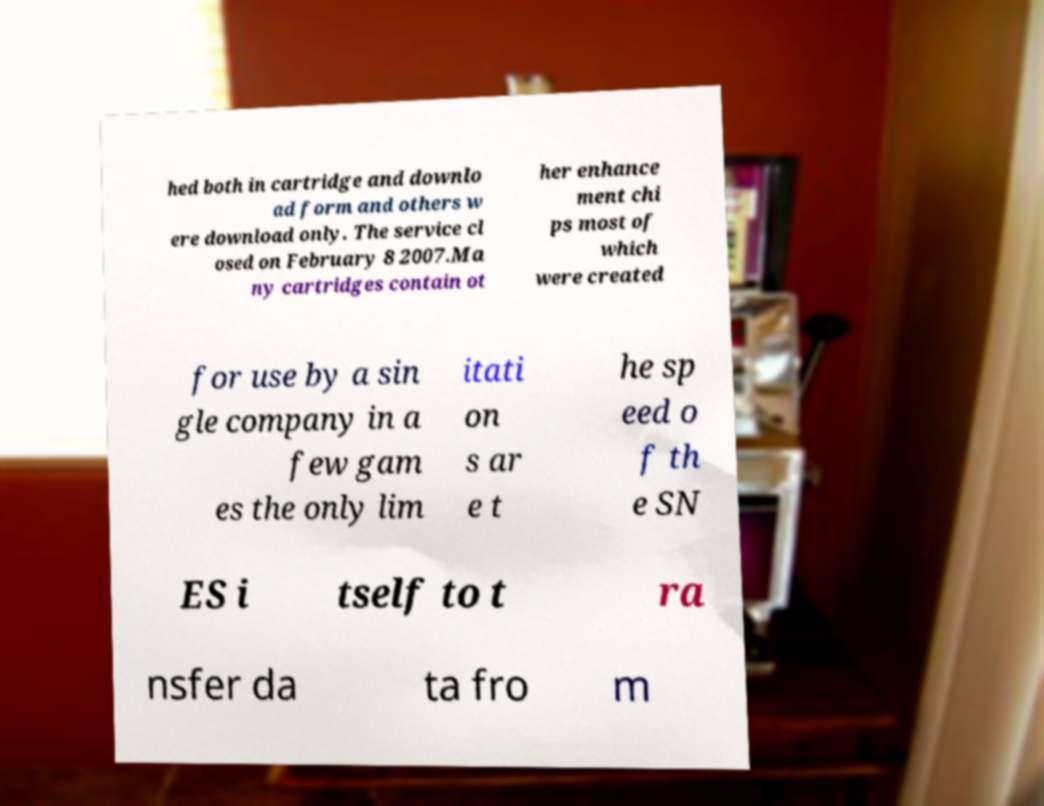I need the written content from this picture converted into text. Can you do that? hed both in cartridge and downlo ad form and others w ere download only. The service cl osed on February 8 2007.Ma ny cartridges contain ot her enhance ment chi ps most of which were created for use by a sin gle company in a few gam es the only lim itati on s ar e t he sp eed o f th e SN ES i tself to t ra nsfer da ta fro m 